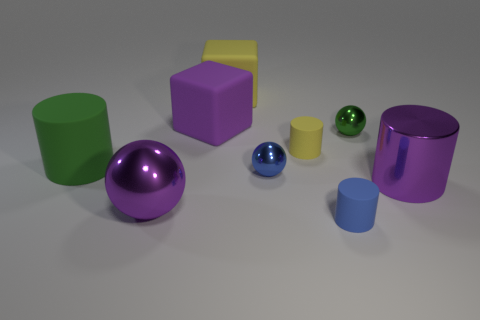Are the big purple cylinder and the big cylinder that is on the left side of the yellow rubber cylinder made of the same material?
Your response must be concise. No. Is the number of large green matte things to the left of the big green matte cylinder less than the number of small green shiny objects in front of the big metal cylinder?
Give a very brief answer. No. What is the color of the large object that is the same material as the purple cylinder?
Give a very brief answer. Purple. Is there a green cylinder right of the blue thing in front of the purple metal cylinder?
Your answer should be very brief. No. What color is the shiny ball that is the same size as the purple block?
Ensure brevity in your answer.  Purple. How many things are either yellow cylinders or large blue matte objects?
Your response must be concise. 1. What is the size of the green object to the right of the big cylinder to the left of the cylinder in front of the big ball?
Your response must be concise. Small. How many rubber cylinders are the same color as the large ball?
Your response must be concise. 0. How many other tiny objects are made of the same material as the tiny yellow object?
Keep it short and to the point. 1. How many things are small blue rubber things or large purple shiny objects that are to the right of the large purple rubber thing?
Make the answer very short. 2. 